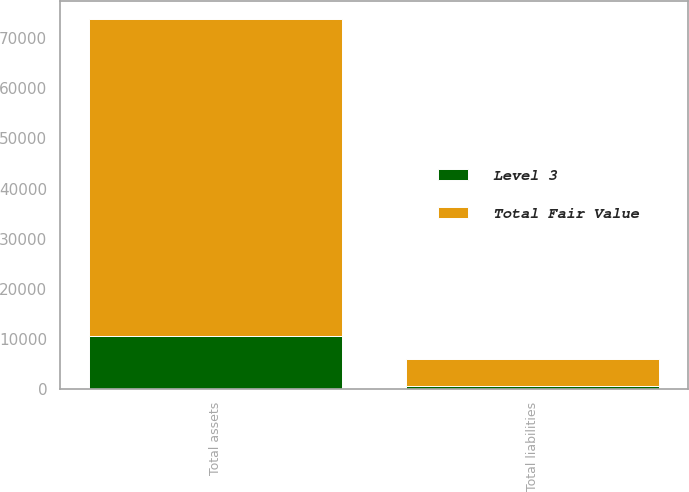Convert chart. <chart><loc_0><loc_0><loc_500><loc_500><stacked_bar_chart><ecel><fcel>Total assets<fcel>Total liabilities<nl><fcel>Total Fair Value<fcel>63096<fcel>5460<nl><fcel>Level 3<fcel>10635<fcel>623<nl></chart> 